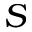<formula> <loc_0><loc_0><loc_500><loc_500>S</formula> 